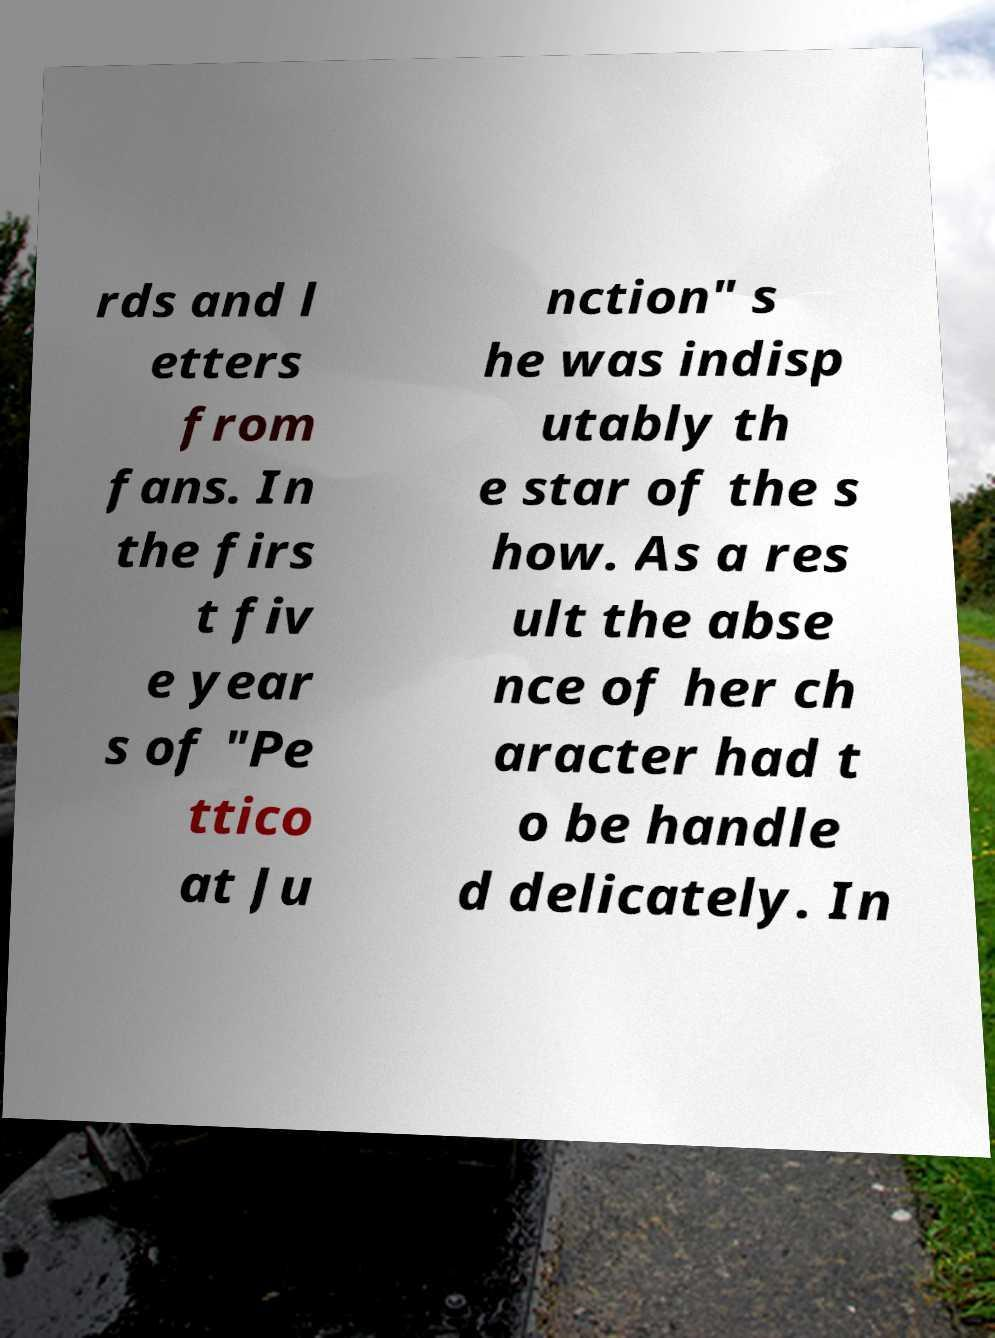What messages or text are displayed in this image? I need them in a readable, typed format. rds and l etters from fans. In the firs t fiv e year s of "Pe ttico at Ju nction" s he was indisp utably th e star of the s how. As a res ult the abse nce of her ch aracter had t o be handle d delicately. In 